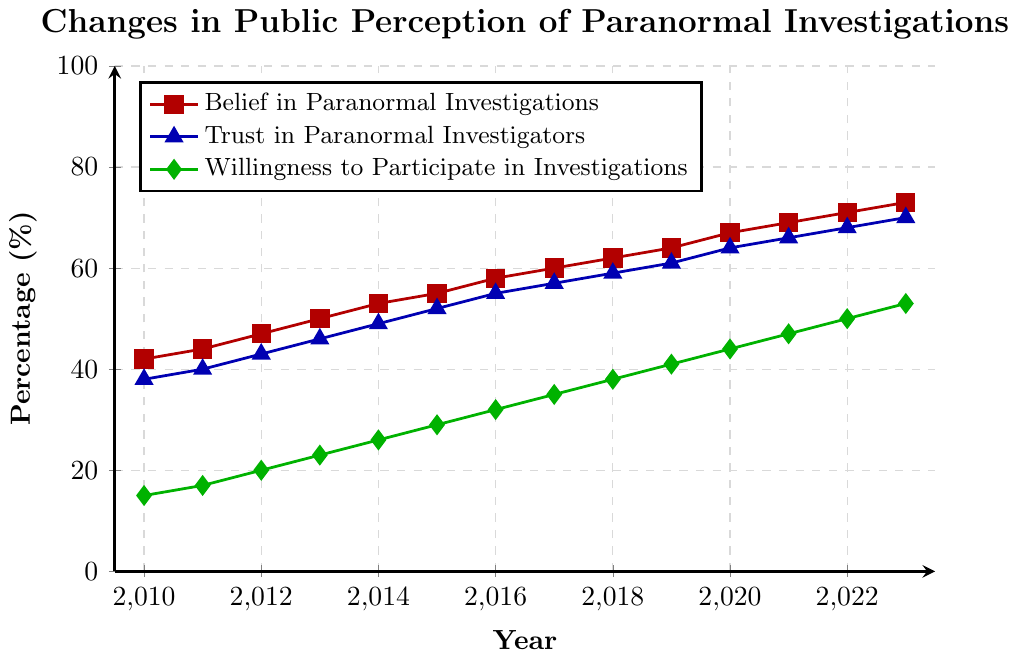What is the trend of "Belief in Paranormal Investigations" over the years? The plot shows a line of "Belief in Paranormal Investigations" marked with red squares, steadily increasing from 2010 to 2023.
Answer: Increasing Which year saw the highest "Trust in Paranormal Investigators"? By examining the data points marked with blue triangles, the year 2023 has the highest value at 70%.
Answer: 2023 How many percentage points did "Willingness to Participate in Investigations" increase from 2010 to 2023? The plot shows 15% in 2010 and 53% in 2023. The difference is calculated as 53% - 15%.
Answer: 38 percentage points Is the gap between "Belief in Paranormal Investigations" and "Willingness to Participate in Investigations" larger in 2010 or in 2023? For 2010, the belief is 42% and willingness is 15%, giving a gap of 27%. For 2023, belief is 73% and willingness is 53%, making a gap of 20%.
Answer: Larger in 2010 Between "Trust in Paranormal Investigators" and "Willingness to Participate in Investigations," which increased at a faster rate from 2010 to 2023? From 2010 to 2023, the increase in trust is 70% - 38% = 32%, while willingness increased from 15% to 53%, which is 38%.
Answer: Willingness to Participate in Investigations What color represents the "Willingness to Participate in Investigations" line? The plot indicates the "Willingness to Participate in Investigations" line is shown with green diamonds.
Answer: Green What was the "Trust in Paranormal Investigators" in 2015? The plot shows a blue triangle for 2015 at the value of 52%.
Answer: 52% Which year had an equal increase for both “Belief in Paranormal Investigations” and “Willingness to Participate in Investigations”? Neither variable shows equal increases year-over-year in the data provided. Each year, the increases differ slightly.
Answer: None What is the average "Belief in Paranormal Investigations" between 2010 and 2023? Adding up the percentages from 2010 to 2023: 42+44+47+50+53+55+58+60+62+64+67+69+71+73 = 815, then divide by the number of years (14).
Answer: 58.21 